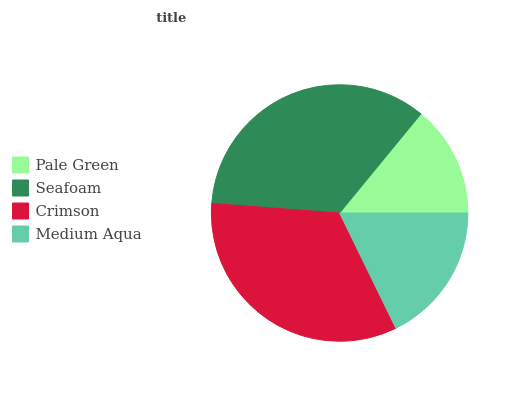Is Pale Green the minimum?
Answer yes or no. Yes. Is Seafoam the maximum?
Answer yes or no. Yes. Is Crimson the minimum?
Answer yes or no. No. Is Crimson the maximum?
Answer yes or no. No. Is Seafoam greater than Crimson?
Answer yes or no. Yes. Is Crimson less than Seafoam?
Answer yes or no. Yes. Is Crimson greater than Seafoam?
Answer yes or no. No. Is Seafoam less than Crimson?
Answer yes or no. No. Is Crimson the high median?
Answer yes or no. Yes. Is Medium Aqua the low median?
Answer yes or no. Yes. Is Pale Green the high median?
Answer yes or no. No. Is Seafoam the low median?
Answer yes or no. No. 